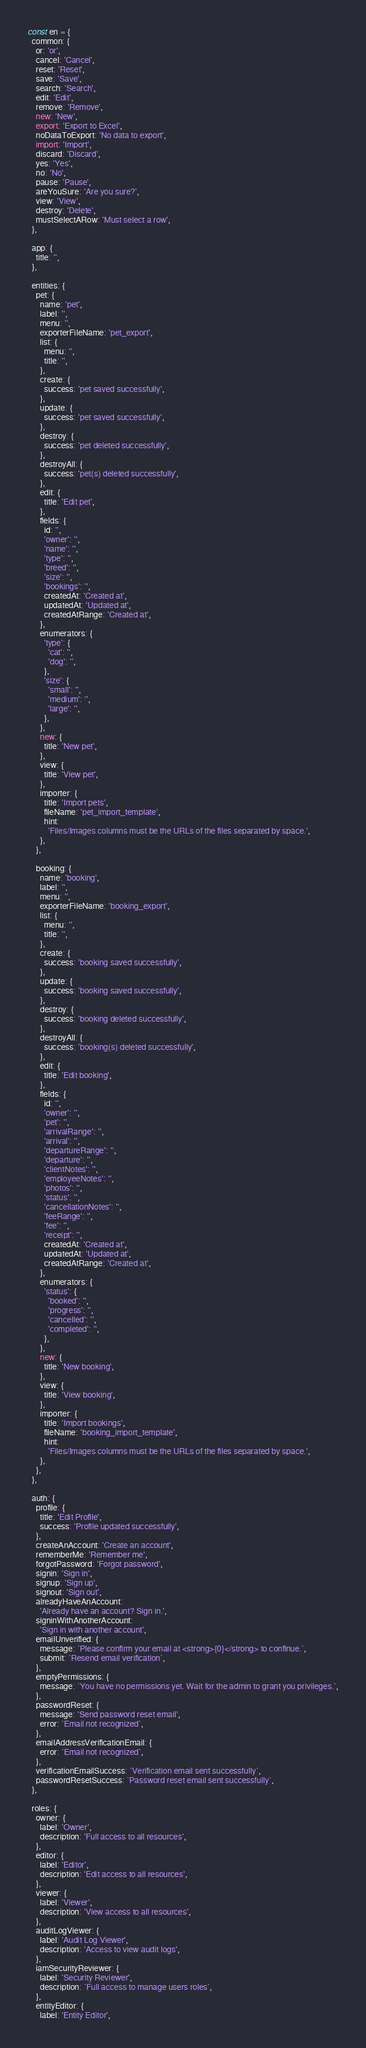Convert code to text. <code><loc_0><loc_0><loc_500><loc_500><_JavaScript_>const en = {
  common: {
    or: 'or',
    cancel: 'Cancel',
    reset: 'Reset',
    save: 'Save',
    search: 'Search',
    edit: 'Edit',
    remove: 'Remove',
    new: 'New',
    export: 'Export to Excel',
    noDataToExport: 'No data to export',
    import: 'Import',
    discard: 'Discard',
    yes: 'Yes',
    no: 'No',
    pause: 'Pause',
    areYouSure: 'Are you sure?',
    view: 'View',
    destroy: 'Delete',
    mustSelectARow: 'Must select a row',
  },

  app: {
    title: '',
  },

  entities: {
    pet: {
      name: 'pet',
      label: '',
      menu: '',
      exporterFileName: 'pet_export',
      list: {
        menu: '',
        title: '',
      },
      create: {
        success: 'pet saved successfully',
      },
      update: {
        success: 'pet saved successfully',
      },
      destroy: {
        success: 'pet deleted successfully',
      },
      destroyAll: {
        success: 'pet(s) deleted successfully',
      },
      edit: {
        title: 'Edit pet',
      },
      fields: {
        id: '',
        'owner': '',
        'name': '',
        'type': '',
        'breed': '',
        'size': '',
        'bookings': '',
        createdAt: 'Created at',
        updatedAt: 'Updated at',
        createdAtRange: 'Created at',
      },
      enumerators: {
        'type': {
          'cat': '',
          'dog': '',
        },
        'size': {
          'small': '',
          'medium': '',
          'large': '',
        },
      },
      new: {
        title: 'New pet',
      },
      view: {
        title: 'View pet',
      },
      importer: {
        title: 'Import pets',
        fileName: 'pet_import_template',
        hint:
          'Files/Images columns must be the URLs of the files separated by space.',
      },
    },

    booking: {
      name: 'booking',
      label: '',
      menu: '',
      exporterFileName: 'booking_export',
      list: {
        menu: '',
        title: '',
      },
      create: {
        success: 'booking saved successfully',
      },
      update: {
        success: 'booking saved successfully',
      },
      destroy: {
        success: 'booking deleted successfully',
      },
      destroyAll: {
        success: 'booking(s) deleted successfully',
      },
      edit: {
        title: 'Edit booking',
      },
      fields: {
        id: '',
        'owner': '',
        'pet': '',
        'arrivalRange': '',
        'arrival': '',
        'departureRange': '',
        'departure': '',
        'clientNotes': '',
        'employeeNotes': '',
        'photos': '',
        'status': '',
        'cancellationNotes': '',
        'feeRange': '',
        'fee': '',
        'receipt': '',
        createdAt: 'Created at',
        updatedAt: 'Updated at',
        createdAtRange: 'Created at',
      },
      enumerators: {
        'status': {
          'booked': '',
          'progress': '',
          'cancelled': '',
          'completed': '',
        },
      },
      new: {
        title: 'New booking',
      },
      view: {
        title: 'View booking',
      },
      importer: {
        title: 'Import bookings',
        fileName: 'booking_import_template',
        hint:
          'Files/Images columns must be the URLs of the files separated by space.',
      },
    },
  },

  auth: {
    profile: {
      title: 'Edit Profile',
      success: 'Profile updated successfully',
    },
    createAnAccount: 'Create an account',
    rememberMe: 'Remember me',
    forgotPassword: 'Forgot password',
    signin: 'Sign in',
    signup: 'Sign up',
    signout: 'Sign out',
    alreadyHaveAnAccount:
      'Already have an account? Sign in.',
    signinWithAnotherAccount:
      'Sign in with another account',
    emailUnverified: {
      message: `Please confirm your email at <strong>{0}</strong> to confinue.`,
      submit: `Resend email verification`,
    },
    emptyPermissions: {
      message: `You have no permissions yet. Wait for the admin to grant you privileges.`,
    },
    passwordReset: {
      message: 'Send password reset email',
      error: `Email not recognized`,
    },
    emailAddressVerificationEmail: {
      error: `Email not recognized`,
    },
    verificationEmailSuccess: `Verification email sent successfully`,
    passwordResetSuccess: `Password reset email sent successfully`,
  },

  roles: {
    owner: {
      label: 'Owner',
      description: 'Full access to all resources',
    },
    editor: {
      label: 'Editor',
      description: 'Edit access to all resources',
    },
    viewer: {
      label: 'Viewer',
      description: 'View access to all resources',
    },
    auditLogViewer: {
      label: 'Audit Log Viewer',
      description: 'Access to view audit logs',
    },
    iamSecurityReviewer: {
      label: 'Security Reviewer',
      description: `Full access to manage users roles`,
    },
    entityEditor: {
      label: 'Entity Editor',</code> 